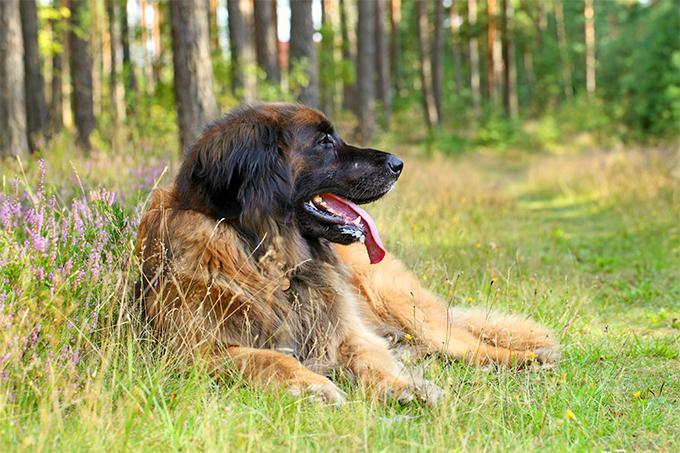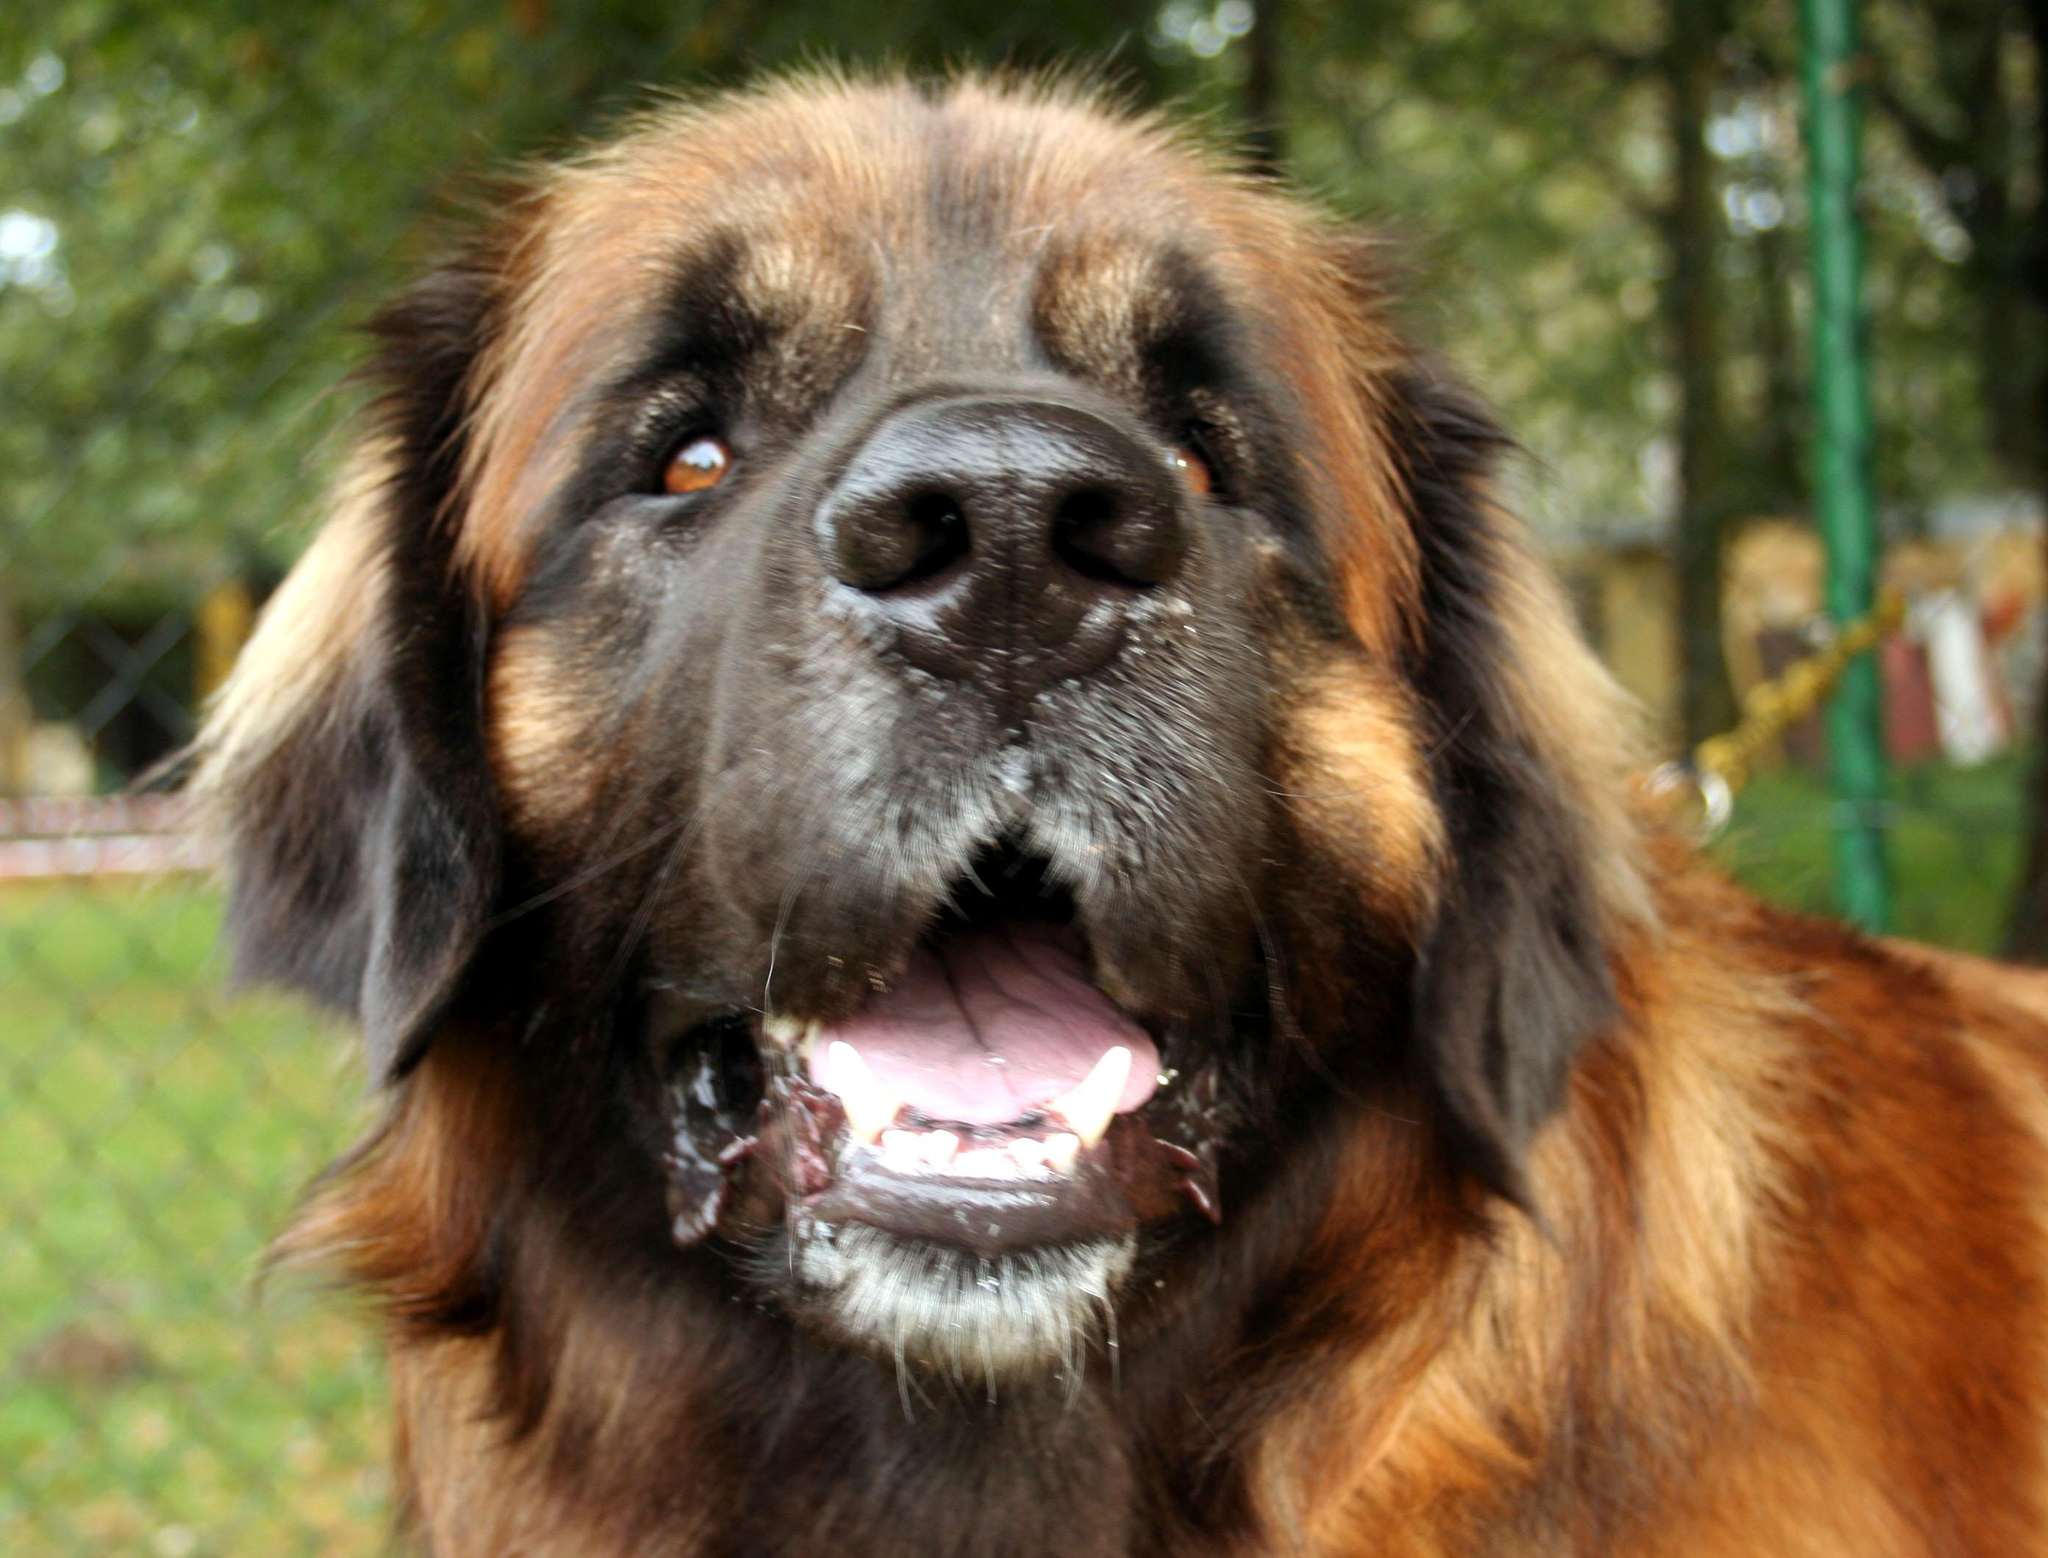The first image is the image on the left, the second image is the image on the right. Given the left and right images, does the statement "The dog in the left image is looking towards the right with its tongue hanging out." hold true? Answer yes or no. Yes. 